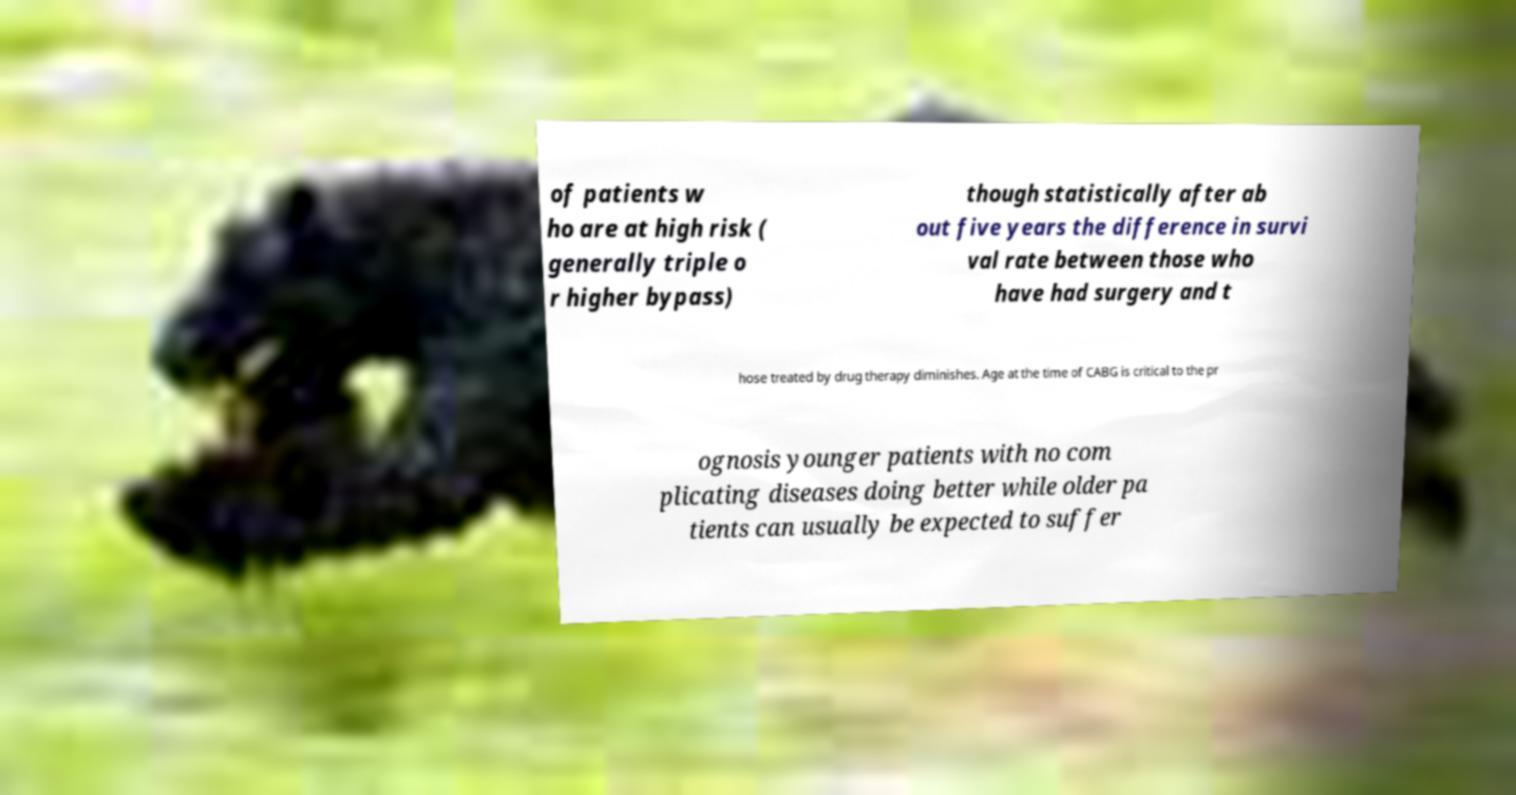Can you read and provide the text displayed in the image?This photo seems to have some interesting text. Can you extract and type it out for me? of patients w ho are at high risk ( generally triple o r higher bypass) though statistically after ab out five years the difference in survi val rate between those who have had surgery and t hose treated by drug therapy diminishes. Age at the time of CABG is critical to the pr ognosis younger patients with no com plicating diseases doing better while older pa tients can usually be expected to suffer 